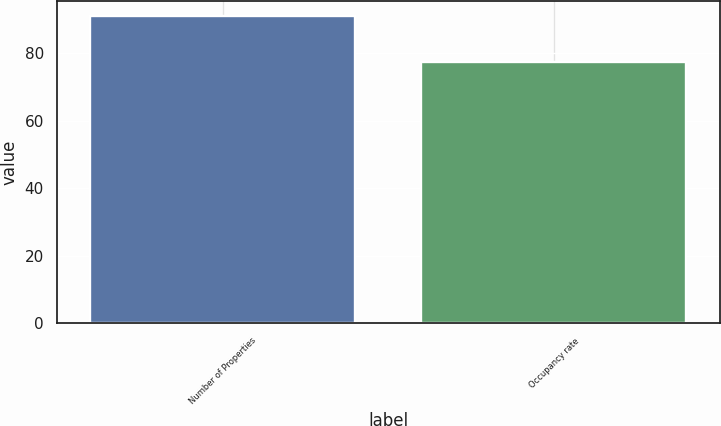Convert chart. <chart><loc_0><loc_0><loc_500><loc_500><bar_chart><fcel>Number of Properties<fcel>Occupancy rate<nl><fcel>91<fcel>77.4<nl></chart> 